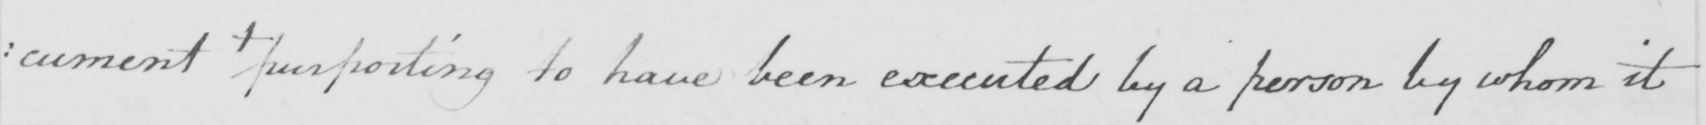What text is written in this handwritten line? : cument  +   purporting to have been executed by a person by whom it 